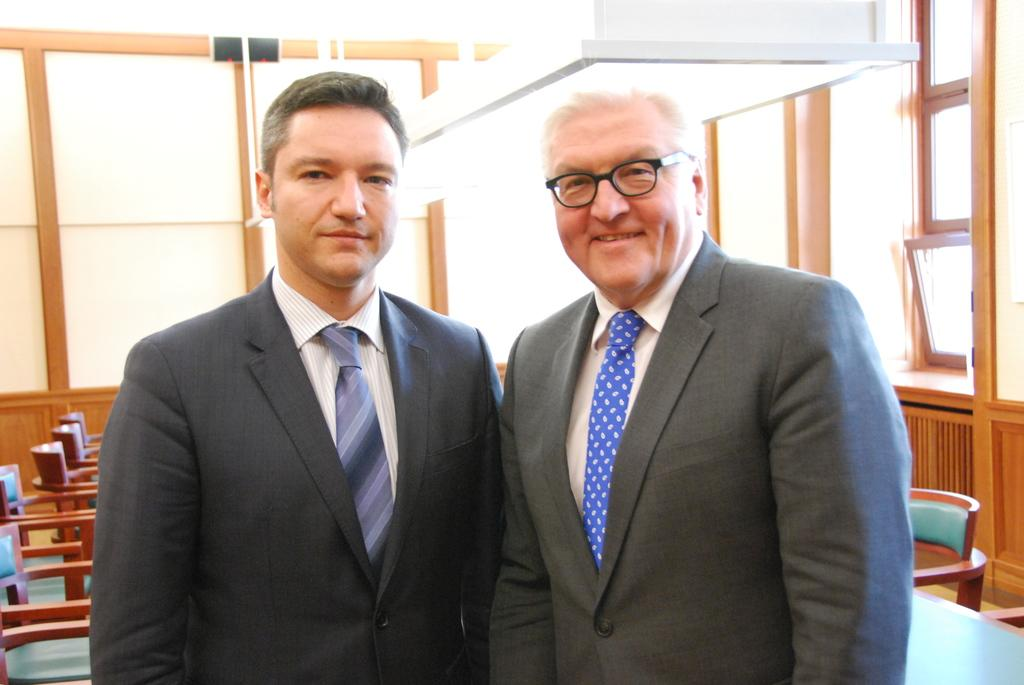How many people are in the picture? There are two men in the picture. What are the men doing in the image? Both men are smiling and posing for a photo. Can you describe the background of the image? There are empty chairs behind the men, and there is a window on the right side of the image. Reasoning: Let' Let's think step by step in order to produce the conversation. We start by identifying the number of people in the image, which is two men. Then, we describe their actions and expressions, noting that they are smiling and posing for a photo. Finally, we describe the background of the image, mentioning the empty chairs and the window. Absurd Question/Answer: What type of pot is visible on the left side of the image? There is no pot present on the left side of the image. How much debt do the men owe in the image? There is no mention of debt in the image; it only shows two men smiling and posing for a photo. What type of pot is visible on the left side of the image? There is no pot present on the left side of the image. How much debt do the men owe in the image? There is no mention of debt in the image; it only shows two men smiling and posing for a photo. 